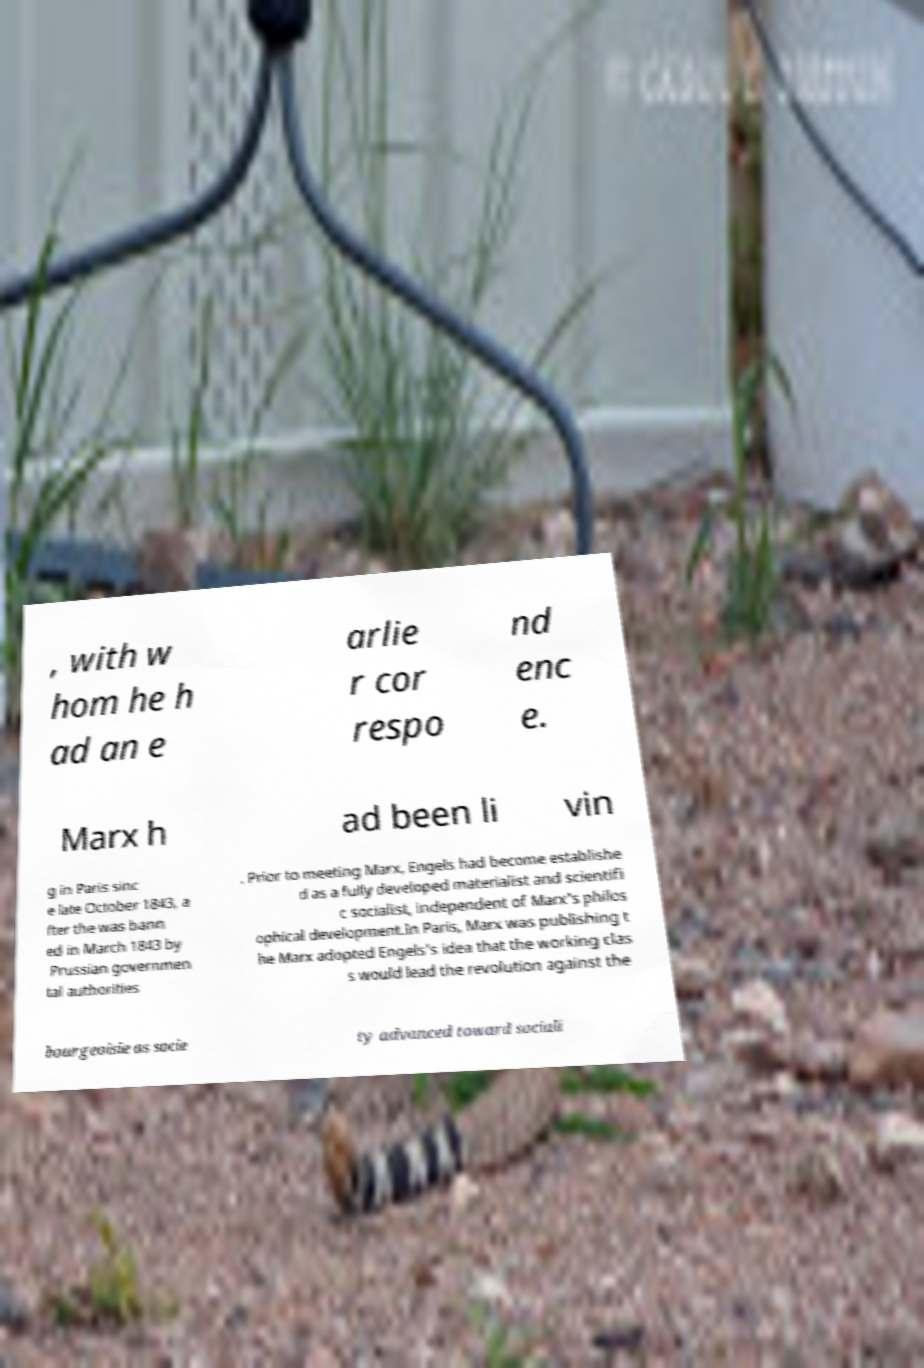Could you extract and type out the text from this image? , with w hom he h ad an e arlie r cor respo nd enc e. Marx h ad been li vin g in Paris sinc e late October 1843, a fter the was bann ed in March 1843 by Prussian governmen tal authorities . Prior to meeting Marx, Engels had become establishe d as a fully developed materialist and scientifi c socialist, independent of Marx's philos ophical development.In Paris, Marx was publishing t he Marx adopted Engels's idea that the working clas s would lead the revolution against the bourgeoisie as socie ty advanced toward sociali 